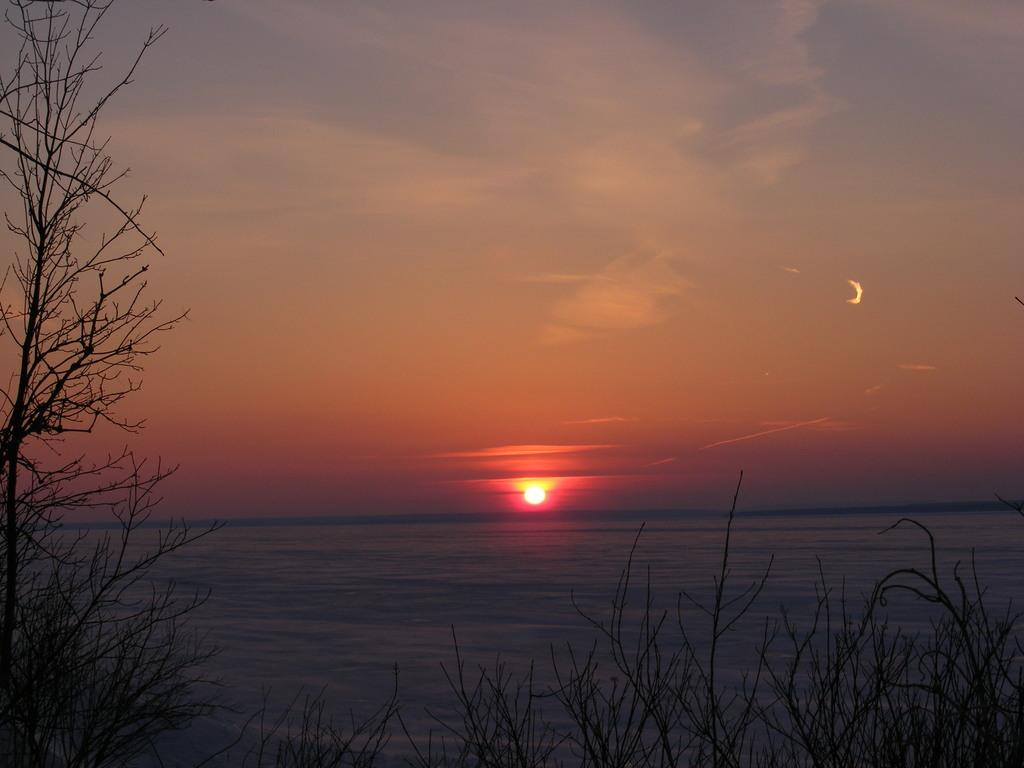What celestial body can be seen in the image? The sun is visible in the image. What type of body of water is present in the image? There is a lake in the image. What type of vegetation is present in the image? Dry trees are present in the image. What is visible in the sky in the image? Clouds are visible in the sky. What type of fuel is being used by the neck in the image? There is no neck or fuel present in the image. How many pairs of scissors can be seen in the image? There are no scissors present in the image. 